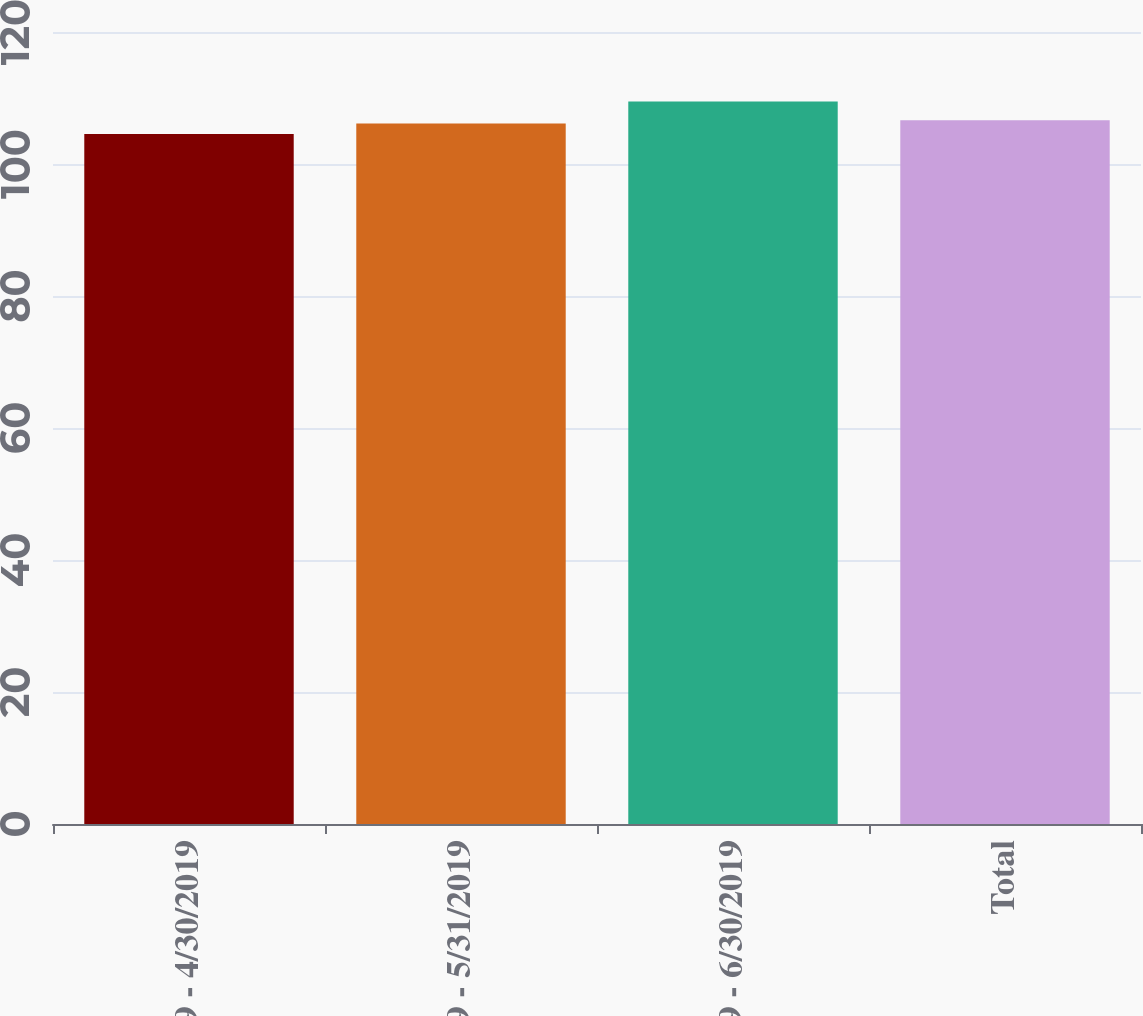Convert chart. <chart><loc_0><loc_0><loc_500><loc_500><bar_chart><fcel>4/1/2019 - 4/30/2019<fcel>5/1/2019 - 5/31/2019<fcel>6/1/2019 - 6/30/2019<fcel>Total<nl><fcel>104.54<fcel>106.12<fcel>109.47<fcel>106.61<nl></chart> 